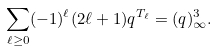<formula> <loc_0><loc_0><loc_500><loc_500>\sum _ { \ell \geq 0 } ( - 1 ) ^ { \ell } ( 2 \ell + 1 ) q ^ { T _ { \ell } } = ( q ) _ { \infty } ^ { 3 } .</formula> 